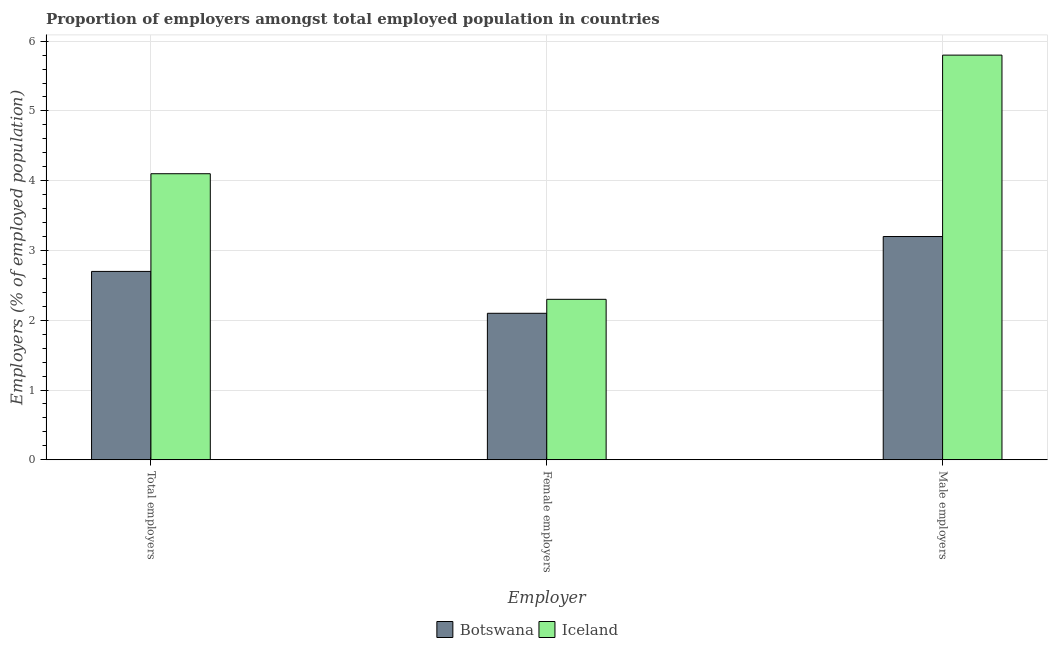Are the number of bars per tick equal to the number of legend labels?
Ensure brevity in your answer.  Yes. What is the label of the 1st group of bars from the left?
Your answer should be compact. Total employers. What is the percentage of female employers in Iceland?
Your answer should be very brief. 2.3. Across all countries, what is the maximum percentage of male employers?
Offer a terse response. 5.8. Across all countries, what is the minimum percentage of female employers?
Keep it short and to the point. 2.1. In which country was the percentage of total employers maximum?
Offer a very short reply. Iceland. In which country was the percentage of female employers minimum?
Your answer should be compact. Botswana. What is the total percentage of male employers in the graph?
Offer a terse response. 9. What is the difference between the percentage of male employers in Botswana and that in Iceland?
Offer a very short reply. -2.6. What is the difference between the percentage of female employers in Botswana and the percentage of total employers in Iceland?
Your response must be concise. -2. What is the average percentage of total employers per country?
Ensure brevity in your answer.  3.4. What is the difference between the percentage of male employers and percentage of total employers in Botswana?
Offer a very short reply. 0.5. What is the ratio of the percentage of total employers in Botswana to that in Iceland?
Make the answer very short. 0.66. Is the percentage of female employers in Iceland less than that in Botswana?
Your answer should be very brief. No. What is the difference between the highest and the second highest percentage of total employers?
Provide a succinct answer. 1.4. What is the difference between the highest and the lowest percentage of male employers?
Offer a very short reply. 2.6. In how many countries, is the percentage of male employers greater than the average percentage of male employers taken over all countries?
Offer a terse response. 1. What does the 2nd bar from the right in Male employers represents?
Make the answer very short. Botswana. Is it the case that in every country, the sum of the percentage of total employers and percentage of female employers is greater than the percentage of male employers?
Your answer should be very brief. Yes. How many bars are there?
Make the answer very short. 6. How many countries are there in the graph?
Your response must be concise. 2. What is the difference between two consecutive major ticks on the Y-axis?
Ensure brevity in your answer.  1. Are the values on the major ticks of Y-axis written in scientific E-notation?
Offer a terse response. No. Does the graph contain grids?
Offer a terse response. Yes. How many legend labels are there?
Keep it short and to the point. 2. What is the title of the graph?
Ensure brevity in your answer.  Proportion of employers amongst total employed population in countries. Does "El Salvador" appear as one of the legend labels in the graph?
Keep it short and to the point. No. What is the label or title of the X-axis?
Your answer should be compact. Employer. What is the label or title of the Y-axis?
Offer a terse response. Employers (% of employed population). What is the Employers (% of employed population) of Botswana in Total employers?
Ensure brevity in your answer.  2.7. What is the Employers (% of employed population) of Iceland in Total employers?
Make the answer very short. 4.1. What is the Employers (% of employed population) of Botswana in Female employers?
Offer a very short reply. 2.1. What is the Employers (% of employed population) of Iceland in Female employers?
Offer a very short reply. 2.3. What is the Employers (% of employed population) in Botswana in Male employers?
Offer a terse response. 3.2. What is the Employers (% of employed population) of Iceland in Male employers?
Your answer should be very brief. 5.8. Across all Employer, what is the maximum Employers (% of employed population) in Botswana?
Offer a terse response. 3.2. Across all Employer, what is the maximum Employers (% of employed population) of Iceland?
Your answer should be compact. 5.8. Across all Employer, what is the minimum Employers (% of employed population) in Botswana?
Make the answer very short. 2.1. Across all Employer, what is the minimum Employers (% of employed population) in Iceland?
Give a very brief answer. 2.3. What is the total Employers (% of employed population) in Botswana in the graph?
Give a very brief answer. 8. What is the total Employers (% of employed population) in Iceland in the graph?
Your answer should be compact. 12.2. What is the difference between the Employers (% of employed population) of Botswana in Female employers and that in Male employers?
Your answer should be very brief. -1.1. What is the difference between the Employers (% of employed population) of Botswana in Total employers and the Employers (% of employed population) of Iceland in Female employers?
Provide a succinct answer. 0.4. What is the average Employers (% of employed population) of Botswana per Employer?
Make the answer very short. 2.67. What is the average Employers (% of employed population) of Iceland per Employer?
Make the answer very short. 4.07. What is the difference between the Employers (% of employed population) of Botswana and Employers (% of employed population) of Iceland in Total employers?
Offer a very short reply. -1.4. What is the difference between the Employers (% of employed population) of Botswana and Employers (% of employed population) of Iceland in Female employers?
Provide a short and direct response. -0.2. What is the difference between the Employers (% of employed population) of Botswana and Employers (% of employed population) of Iceland in Male employers?
Provide a short and direct response. -2.6. What is the ratio of the Employers (% of employed population) in Botswana in Total employers to that in Female employers?
Keep it short and to the point. 1.29. What is the ratio of the Employers (% of employed population) in Iceland in Total employers to that in Female employers?
Your answer should be compact. 1.78. What is the ratio of the Employers (% of employed population) in Botswana in Total employers to that in Male employers?
Provide a short and direct response. 0.84. What is the ratio of the Employers (% of employed population) of Iceland in Total employers to that in Male employers?
Give a very brief answer. 0.71. What is the ratio of the Employers (% of employed population) of Botswana in Female employers to that in Male employers?
Offer a very short reply. 0.66. What is the ratio of the Employers (% of employed population) of Iceland in Female employers to that in Male employers?
Provide a short and direct response. 0.4. What is the difference between the highest and the second highest Employers (% of employed population) in Botswana?
Your answer should be compact. 0.5. What is the difference between the highest and the second highest Employers (% of employed population) of Iceland?
Your answer should be very brief. 1.7. 